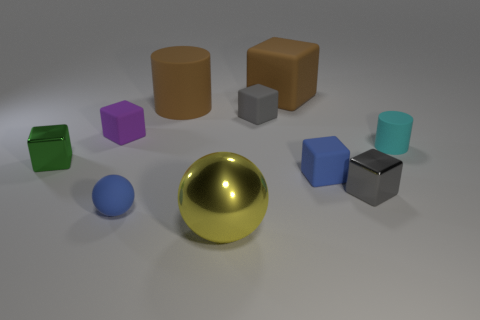Aside from shape, what different characteristics can we observe about the objects in the image? The objects exhibit a variety of colors including gold, cyan, purple, green, blue, and shades of grey and brown. They also show different surface textures and reflectivity; for instance, the golden sphere has a reflective, shiny surface, which contrasts with the more muted and matte appearance of the other objects. 